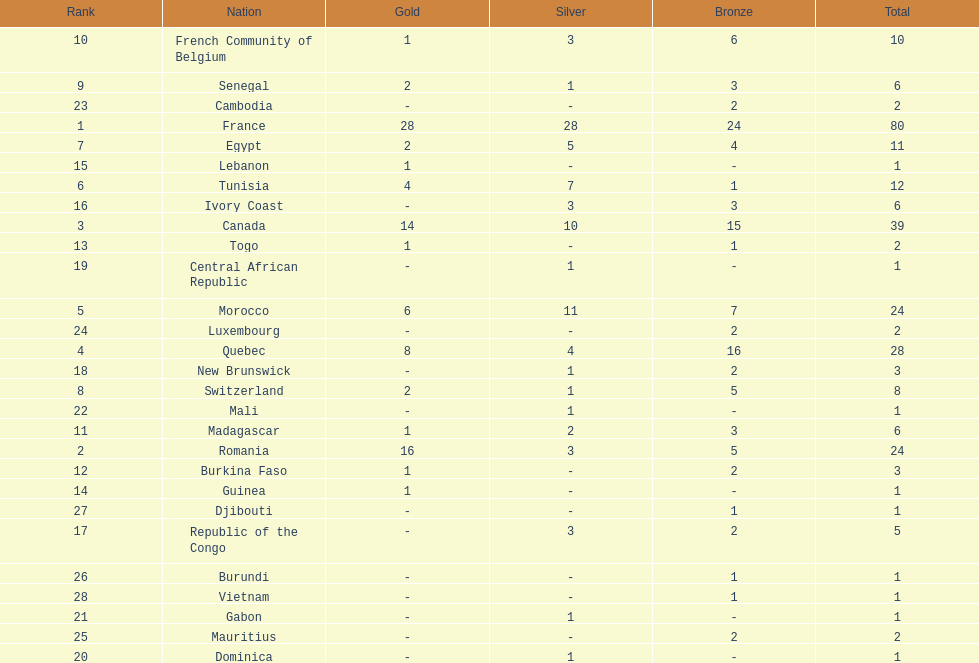What is the difference between france's and egypt's silver medals? 23. 